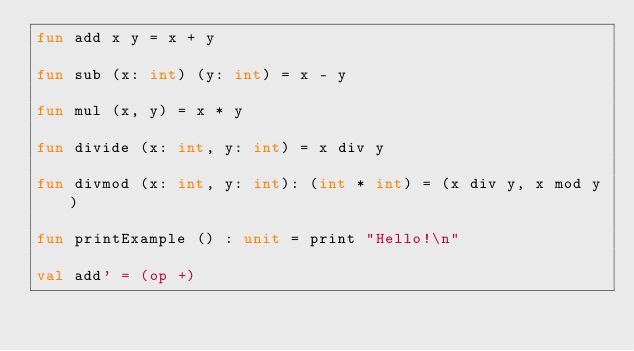Convert code to text. <code><loc_0><loc_0><loc_500><loc_500><_SML_>fun add x y = x + y

fun sub (x: int) (y: int) = x - y

fun mul (x, y) = x * y

fun divide (x: int, y: int) = x div y

fun divmod (x: int, y: int): (int * int) = (x div y, x mod y)

fun printExample () : unit = print "Hello!\n"

val add' = (op +)</code> 